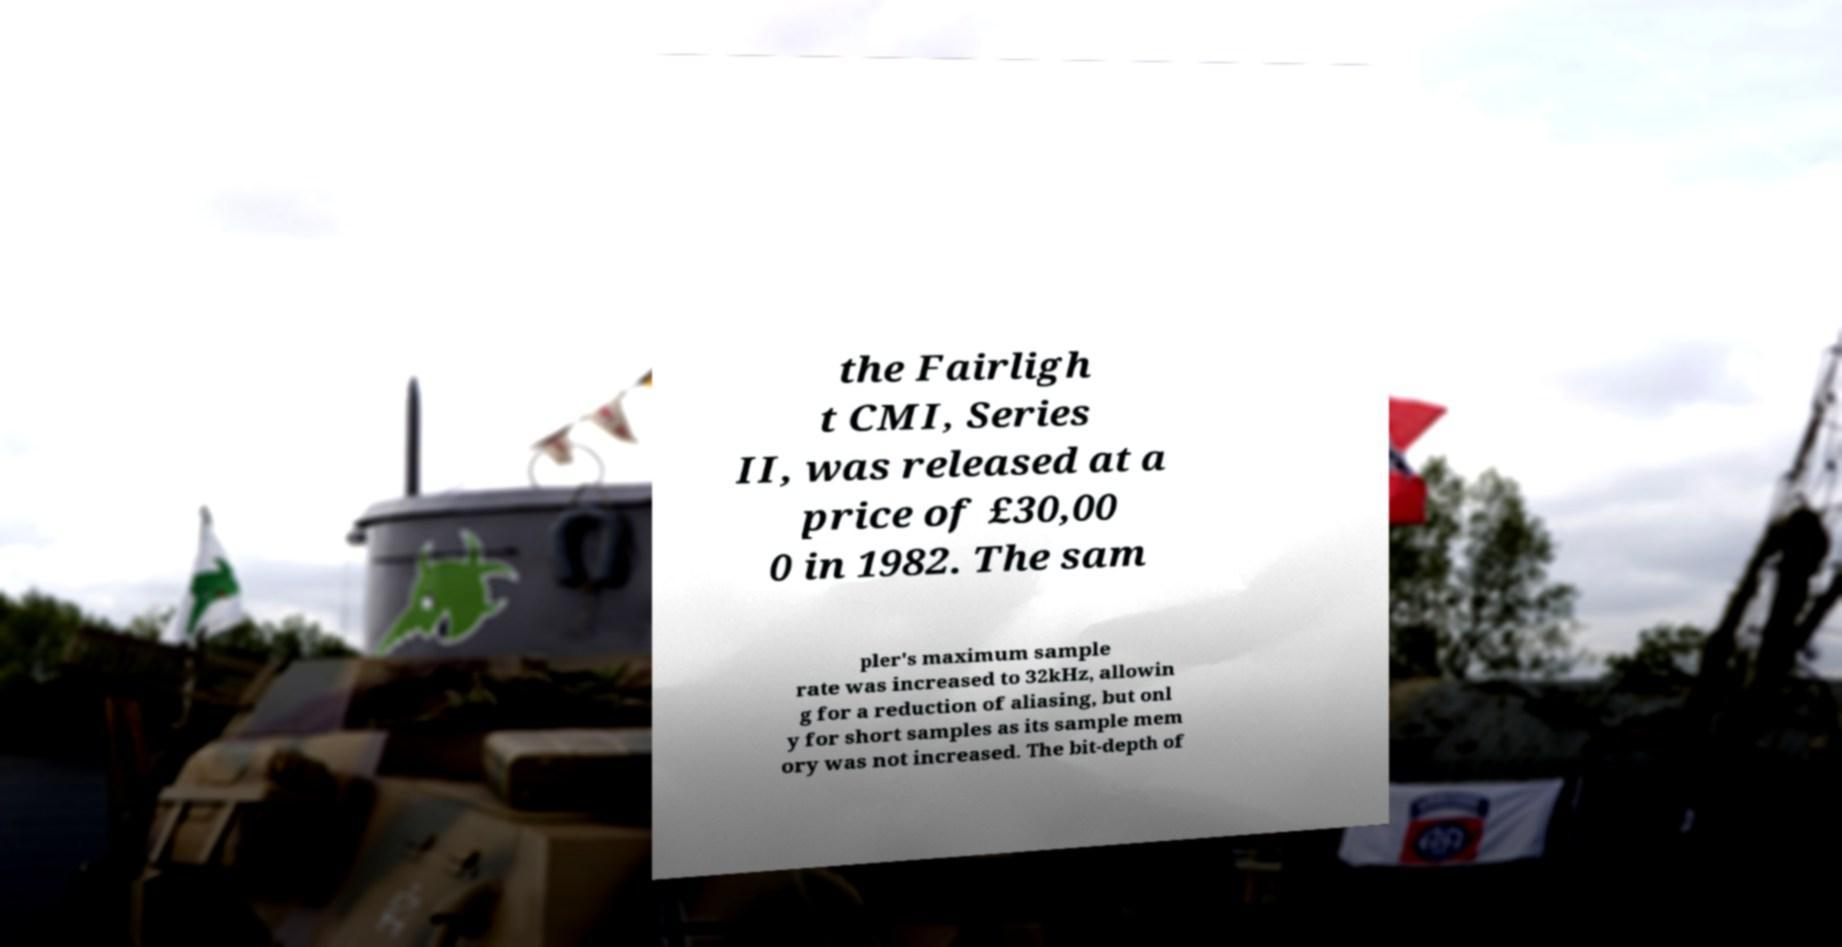What messages or text are displayed in this image? I need them in a readable, typed format. the Fairligh t CMI, Series II, was released at a price of £30,00 0 in 1982. The sam pler's maximum sample rate was increased to 32kHz, allowin g for a reduction of aliasing, but onl y for short samples as its sample mem ory was not increased. The bit-depth of 